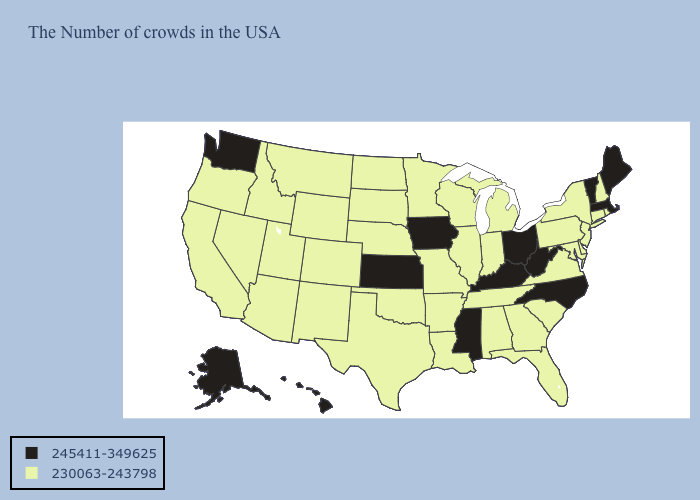What is the lowest value in states that border Nebraska?
Write a very short answer. 230063-243798. What is the highest value in the USA?
Short answer required. 245411-349625. Does Hawaii have a lower value than New Jersey?
Quick response, please. No. Name the states that have a value in the range 245411-349625?
Short answer required. Maine, Massachusetts, Vermont, North Carolina, West Virginia, Ohio, Kentucky, Mississippi, Iowa, Kansas, Washington, Alaska, Hawaii. Name the states that have a value in the range 230063-243798?
Give a very brief answer. Rhode Island, New Hampshire, Connecticut, New York, New Jersey, Delaware, Maryland, Pennsylvania, Virginia, South Carolina, Florida, Georgia, Michigan, Indiana, Alabama, Tennessee, Wisconsin, Illinois, Louisiana, Missouri, Arkansas, Minnesota, Nebraska, Oklahoma, Texas, South Dakota, North Dakota, Wyoming, Colorado, New Mexico, Utah, Montana, Arizona, Idaho, Nevada, California, Oregon. Which states hav the highest value in the MidWest?
Keep it brief. Ohio, Iowa, Kansas. What is the lowest value in states that border Ohio?
Keep it brief. 230063-243798. What is the highest value in the USA?
Write a very short answer. 245411-349625. Among the states that border Virginia , does Maryland have the highest value?
Concise answer only. No. What is the value of Montana?
Write a very short answer. 230063-243798. What is the value of Wisconsin?
Keep it brief. 230063-243798. Name the states that have a value in the range 245411-349625?
Short answer required. Maine, Massachusetts, Vermont, North Carolina, West Virginia, Ohio, Kentucky, Mississippi, Iowa, Kansas, Washington, Alaska, Hawaii. Does the map have missing data?
Keep it brief. No. Which states have the lowest value in the West?
Keep it brief. Wyoming, Colorado, New Mexico, Utah, Montana, Arizona, Idaho, Nevada, California, Oregon. Does Pennsylvania have the same value as North Carolina?
Answer briefly. No. 